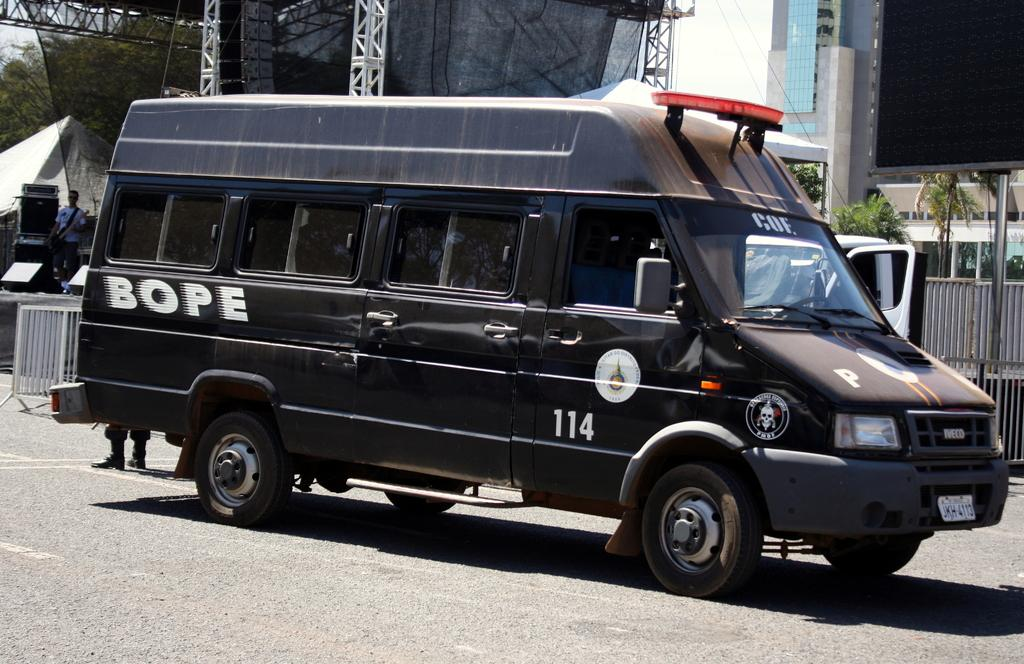<image>
Describe the image concisely. a dark van with a bope decal, and the numbers 114 on the side 